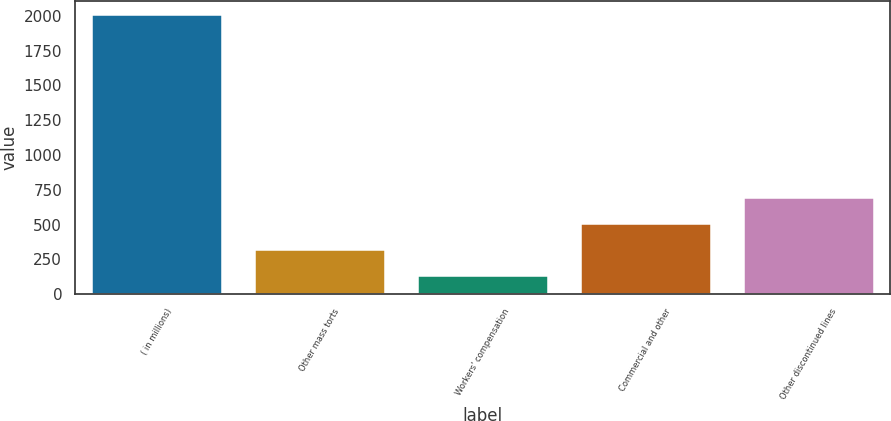Convert chart to OTSL. <chart><loc_0><loc_0><loc_500><loc_500><bar_chart><fcel>( in millions)<fcel>Other mass torts<fcel>Workers' compensation<fcel>Commercial and other<fcel>Other discontinued lines<nl><fcel>2008<fcel>317.8<fcel>130<fcel>505.6<fcel>693.4<nl></chart> 